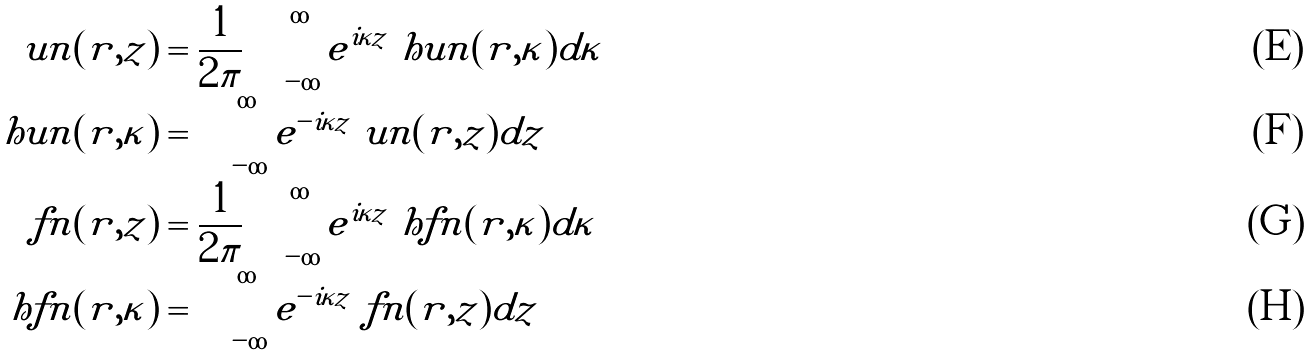Convert formula to latex. <formula><loc_0><loc_0><loc_500><loc_500>\ u n ( r , z ) & = \frac { 1 } { 2 \pi } \int _ { - \infty } ^ { \infty } e ^ { i \kappa z } \ h u n ( r , \kappa ) d \kappa \\ \ h u n ( r , \kappa ) & = \int _ { - \infty } ^ { \infty } e ^ { - i \kappa z } \ u n ( r , z ) d z \\ \ f n ( r , z ) & = \frac { 1 } { 2 \pi } \int _ { - \infty } ^ { \infty } e ^ { i \kappa z } \ h f n ( r , \kappa ) d \kappa \\ \ h f n ( r , \kappa ) & = \int _ { - \infty } ^ { \infty } e ^ { - i \kappa z } \ f n ( r , z ) d z</formula> 